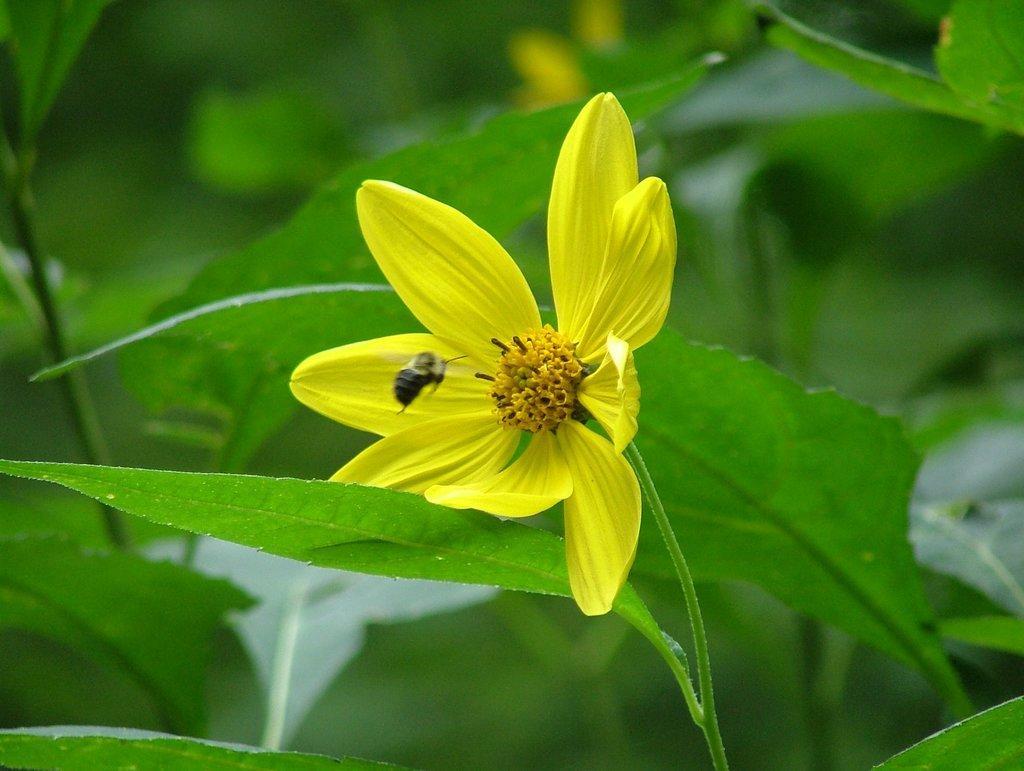Could you give a brief overview of what you see in this image? In this picture we can see a yellow flower and in front of the flower there is an insect and behind the flower there are leaves and blurred background. 